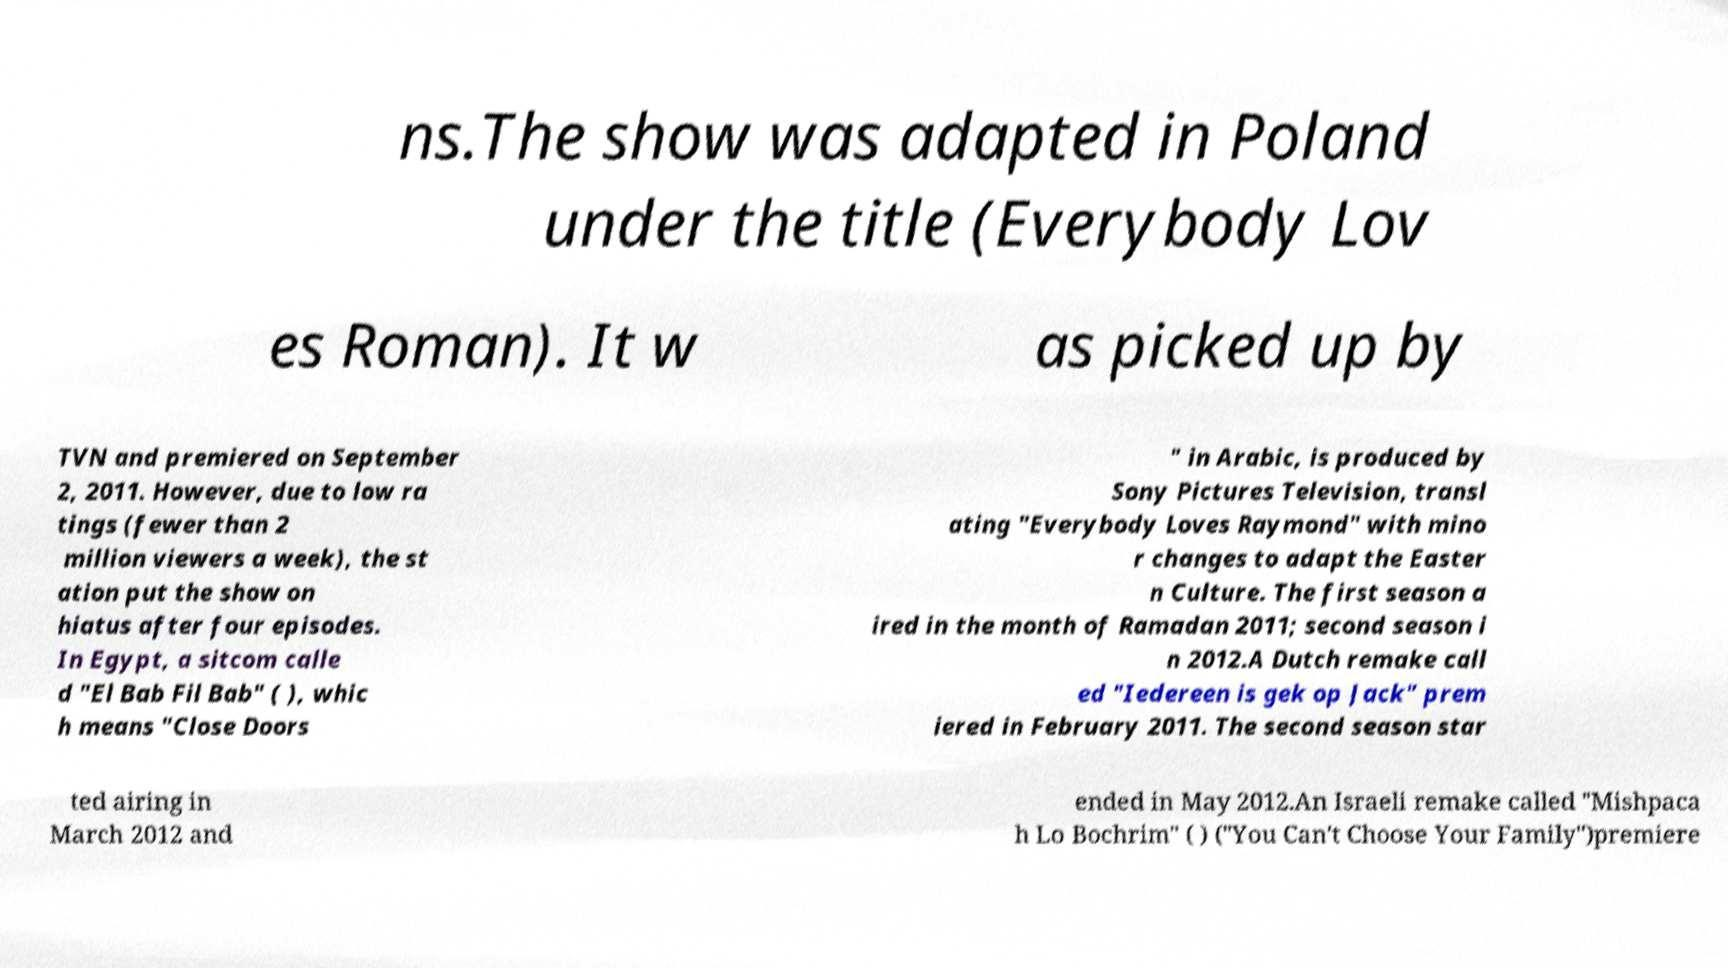Can you read and provide the text displayed in the image?This photo seems to have some interesting text. Can you extract and type it out for me? ns.The show was adapted in Poland under the title (Everybody Lov es Roman). It w as picked up by TVN and premiered on September 2, 2011. However, due to low ra tings (fewer than 2 million viewers a week), the st ation put the show on hiatus after four episodes. In Egypt, a sitcom calle d "El Bab Fil Bab" ( ), whic h means "Close Doors " in Arabic, is produced by Sony Pictures Television, transl ating "Everybody Loves Raymond" with mino r changes to adapt the Easter n Culture. The first season a ired in the month of Ramadan 2011; second season i n 2012.A Dutch remake call ed "Iedereen is gek op Jack" prem iered in February 2011. The second season star ted airing in March 2012 and ended in May 2012.An Israeli remake called "Mishpaca h Lo Bochrim" ( ) ("You Can't Choose Your Family")premiere 